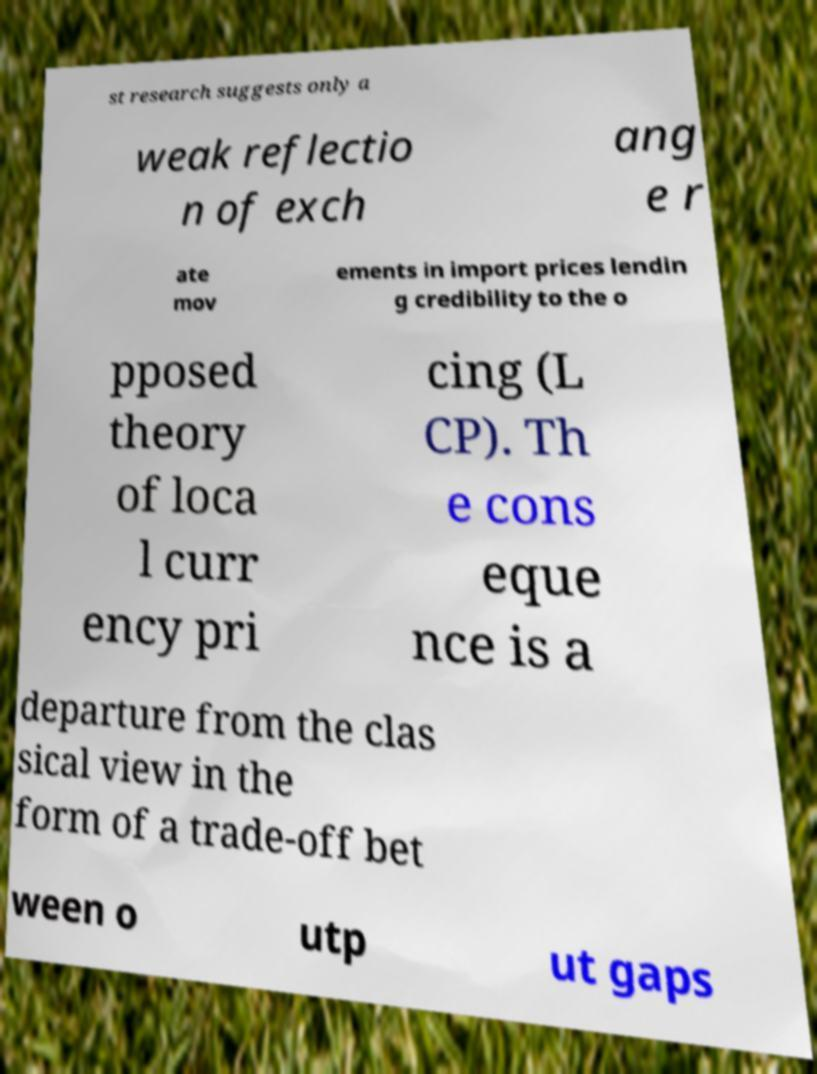For documentation purposes, I need the text within this image transcribed. Could you provide that? st research suggests only a weak reflectio n of exch ang e r ate mov ements in import prices lendin g credibility to the o pposed theory of loca l curr ency pri cing (L CP). Th e cons eque nce is a departure from the clas sical view in the form of a trade-off bet ween o utp ut gaps 